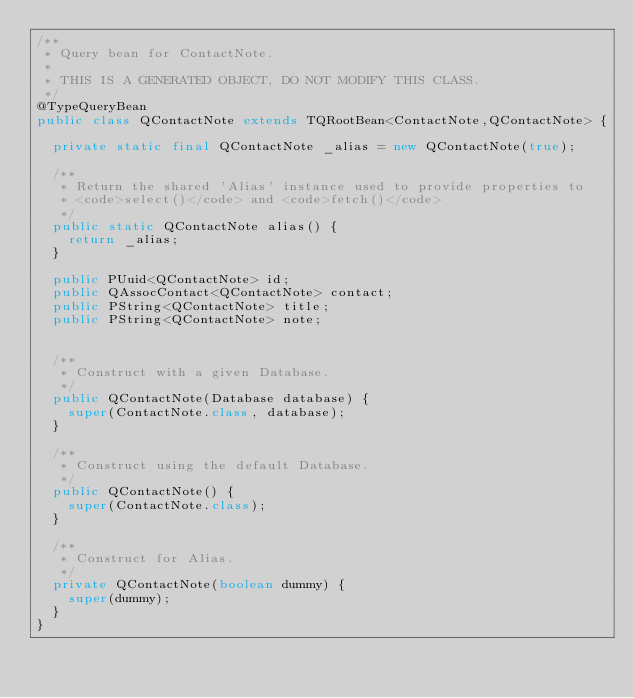<code> <loc_0><loc_0><loc_500><loc_500><_Java_>/**
 * Query bean for ContactNote.
 * 
 * THIS IS A GENERATED OBJECT, DO NOT MODIFY THIS CLASS.
 */
@TypeQueryBean
public class QContactNote extends TQRootBean<ContactNote,QContactNote> {

  private static final QContactNote _alias = new QContactNote(true);

  /**
   * Return the shared 'Alias' instance used to provide properties to 
   * <code>select()</code> and <code>fetch()</code> 
   */
  public static QContactNote alias() {
    return _alias;
  }

  public PUuid<QContactNote> id;
  public QAssocContact<QContactNote> contact;
  public PString<QContactNote> title;
  public PString<QContactNote> note;


  /**
   * Construct with a given Database.
   */
  public QContactNote(Database database) {
    super(ContactNote.class, database);
  }

  /**
   * Construct using the default Database.
   */
  public QContactNote() {
    super(ContactNote.class);
  }

  /**
   * Construct for Alias.
   */
  private QContactNote(boolean dummy) {
    super(dummy);
  }
}
</code> 